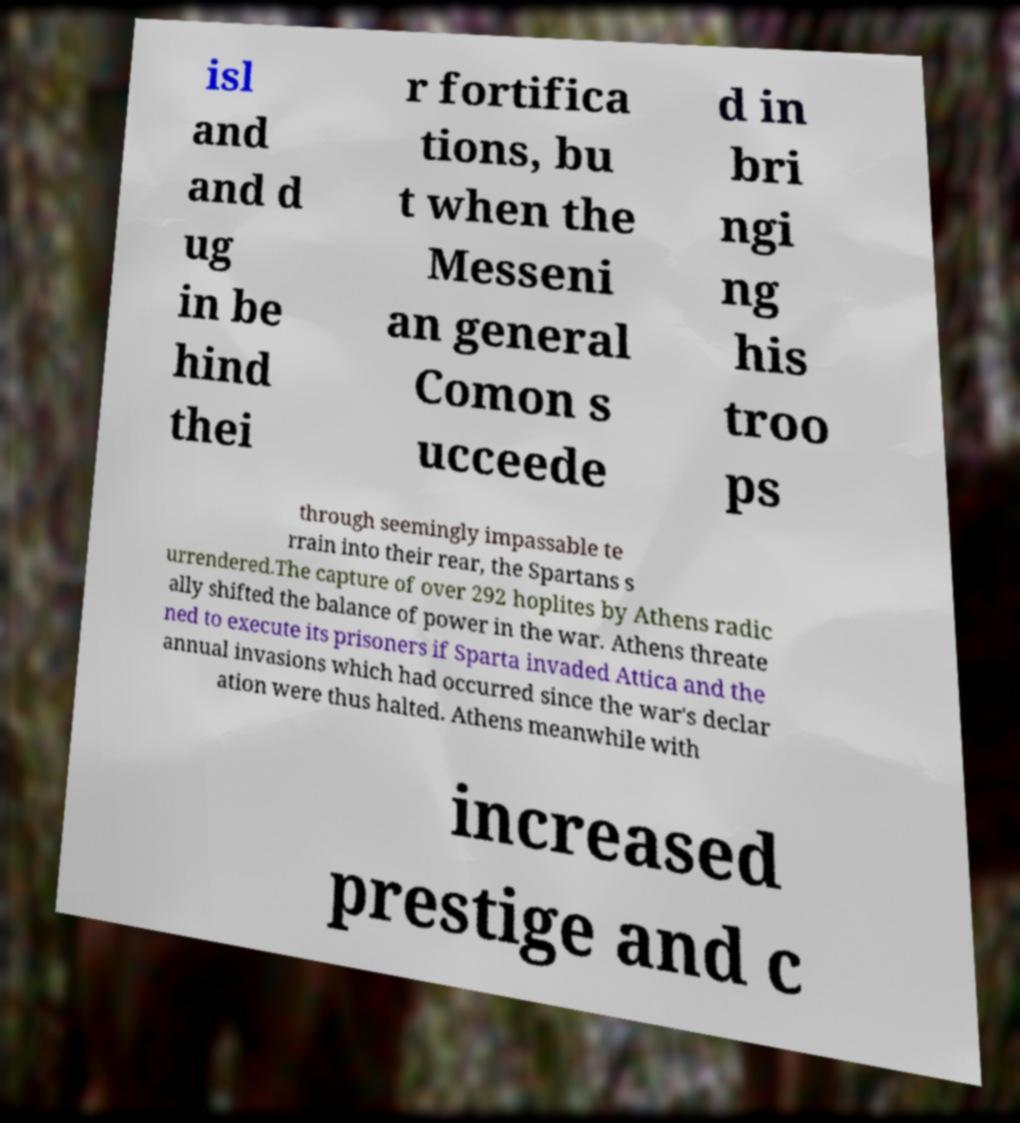Can you read and provide the text displayed in the image?This photo seems to have some interesting text. Can you extract and type it out for me? isl and and d ug in be hind thei r fortifica tions, bu t when the Messeni an general Comon s ucceede d in bri ngi ng his troo ps through seemingly impassable te rrain into their rear, the Spartans s urrendered.The capture of over 292 hoplites by Athens radic ally shifted the balance of power in the war. Athens threate ned to execute its prisoners if Sparta invaded Attica and the annual invasions which had occurred since the war's declar ation were thus halted. Athens meanwhile with increased prestige and c 